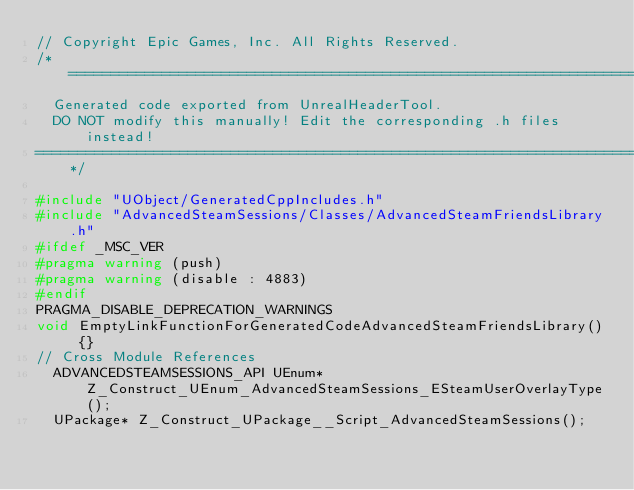<code> <loc_0><loc_0><loc_500><loc_500><_C++_>// Copyright Epic Games, Inc. All Rights Reserved.
/*===========================================================================
	Generated code exported from UnrealHeaderTool.
	DO NOT modify this manually! Edit the corresponding .h files instead!
===========================================================================*/

#include "UObject/GeneratedCppIncludes.h"
#include "AdvancedSteamSessions/Classes/AdvancedSteamFriendsLibrary.h"
#ifdef _MSC_VER
#pragma warning (push)
#pragma warning (disable : 4883)
#endif
PRAGMA_DISABLE_DEPRECATION_WARNINGS
void EmptyLinkFunctionForGeneratedCodeAdvancedSteamFriendsLibrary() {}
// Cross Module References
	ADVANCEDSTEAMSESSIONS_API UEnum* Z_Construct_UEnum_AdvancedSteamSessions_ESteamUserOverlayType();
	UPackage* Z_Construct_UPackage__Script_AdvancedSteamSessions();</code> 